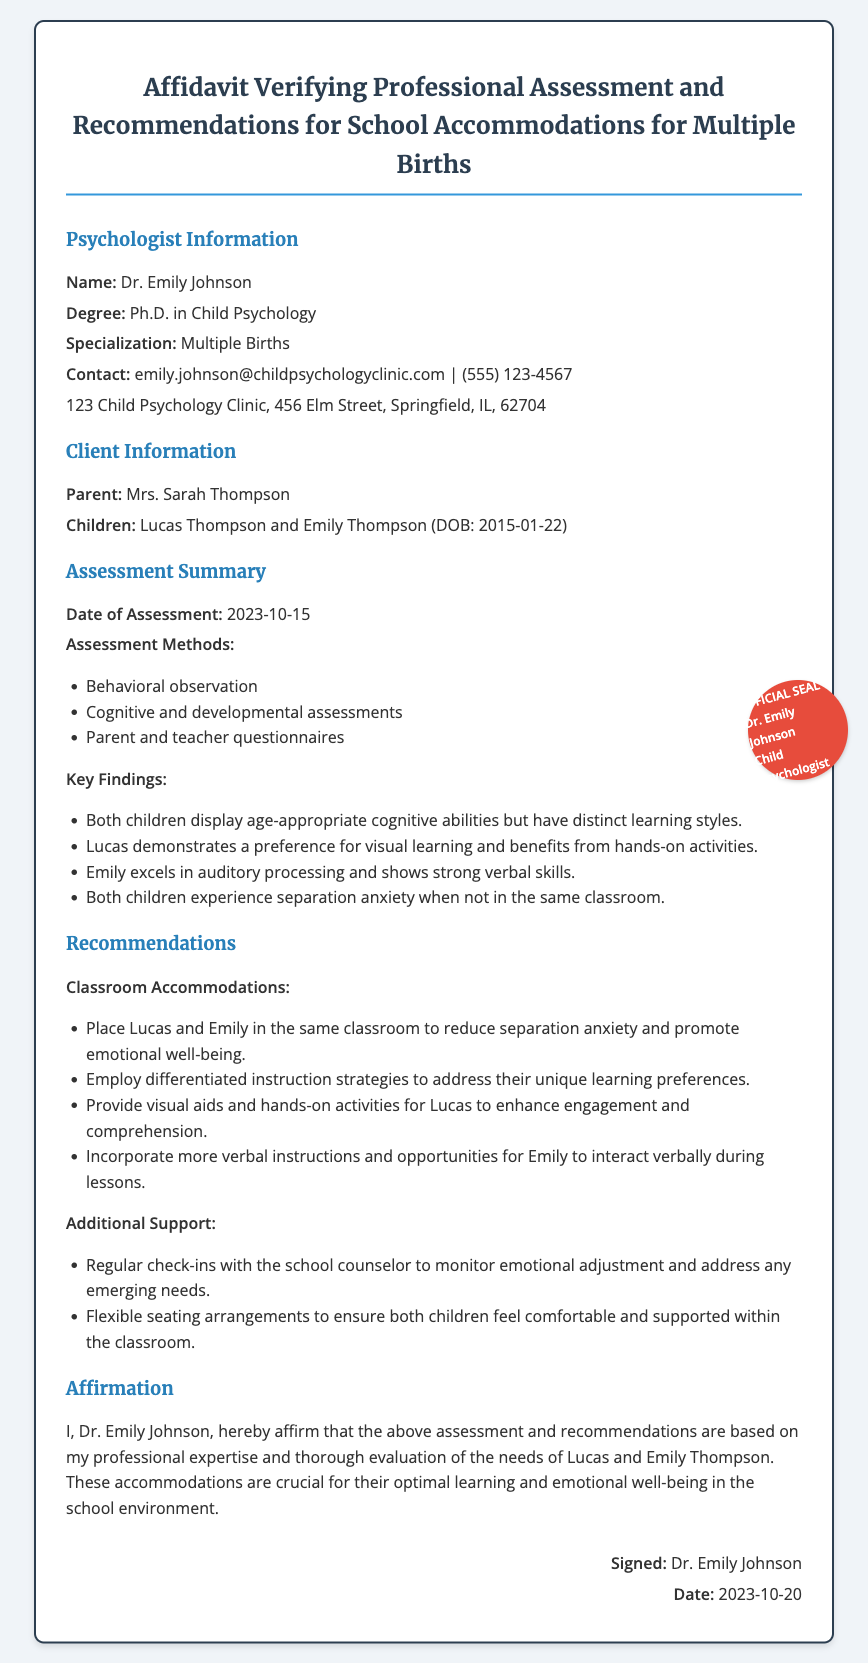What is the name of the psychologist? The psychologist's name is listed in the document under the Psychologist Information section.
Answer: Dr. Emily Johnson What is the degree held by Dr. Emily Johnson? The degree of Dr. Emily Johnson is specified in the document's Psychologist Information section.
Answer: Ph.D. in Child Psychology What are the names of the children assessed? The children's names are mentioned in the Client Information section of the document.
Answer: Lucas Thompson and Emily Thompson What date was the assessment conducted? The date of the assessment is clearly stated in the Assessment Summary section of the affidavit.
Answer: 2023-10-15 What emotional issue do both children experience? The emotional issue both children experience is described in the Key Findings of the Assessment Summary.
Answer: Separation anxiety What is one classroom accommodation recommended for the children? The recommendations include specific accommodations, one of which can be found in the Recommendations section.
Answer: Place Lucas and Emily in the same classroom Who is the parent listed in the document? The document identifies the parent responsible for the children in the Client Information section.
Answer: Mrs. Sarah Thompson What is the date when the affidavit was signed? The signing date can be found in the signature section at the end of the document.
Answer: 2023-10-20 What is the specialization of Dr. Emily Johnson? The specialization of Dr. Emily Johnson is outlined in the Psychologist Information section.
Answer: Multiple Births 